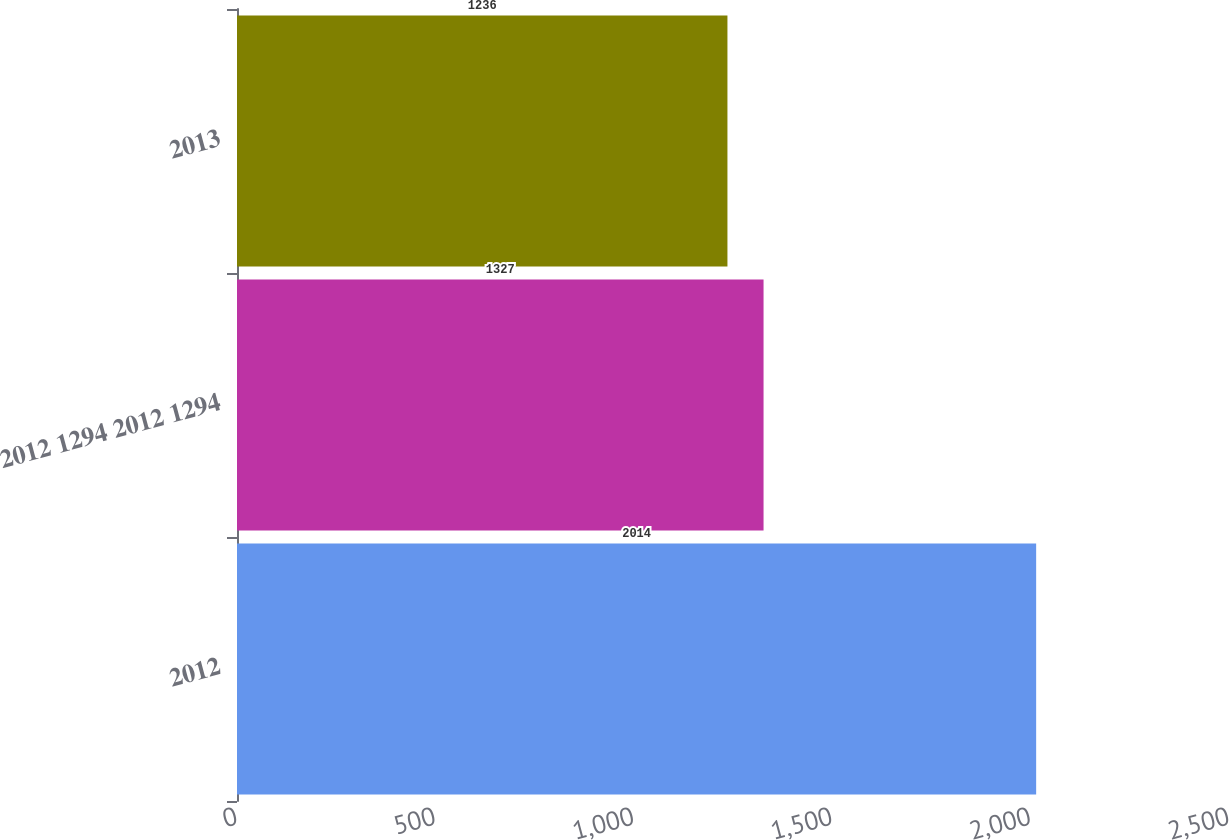<chart> <loc_0><loc_0><loc_500><loc_500><bar_chart><fcel>2012<fcel>2012 1294 2012 1294<fcel>2013<nl><fcel>2014<fcel>1327<fcel>1236<nl></chart> 